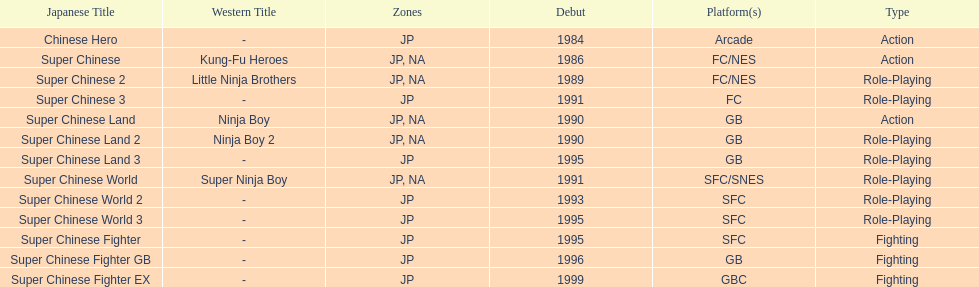Of the titles released in north america, which had the least releases? Super Chinese World. 